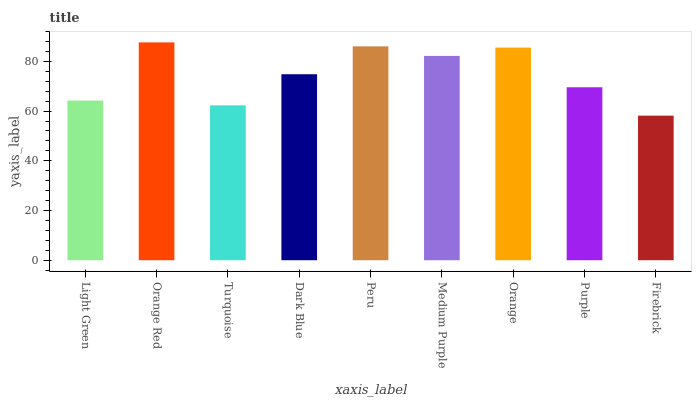Is Firebrick the minimum?
Answer yes or no. Yes. Is Orange Red the maximum?
Answer yes or no. Yes. Is Turquoise the minimum?
Answer yes or no. No. Is Turquoise the maximum?
Answer yes or no. No. Is Orange Red greater than Turquoise?
Answer yes or no. Yes. Is Turquoise less than Orange Red?
Answer yes or no. Yes. Is Turquoise greater than Orange Red?
Answer yes or no. No. Is Orange Red less than Turquoise?
Answer yes or no. No. Is Dark Blue the high median?
Answer yes or no. Yes. Is Dark Blue the low median?
Answer yes or no. Yes. Is Orange the high median?
Answer yes or no. No. Is Peru the low median?
Answer yes or no. No. 